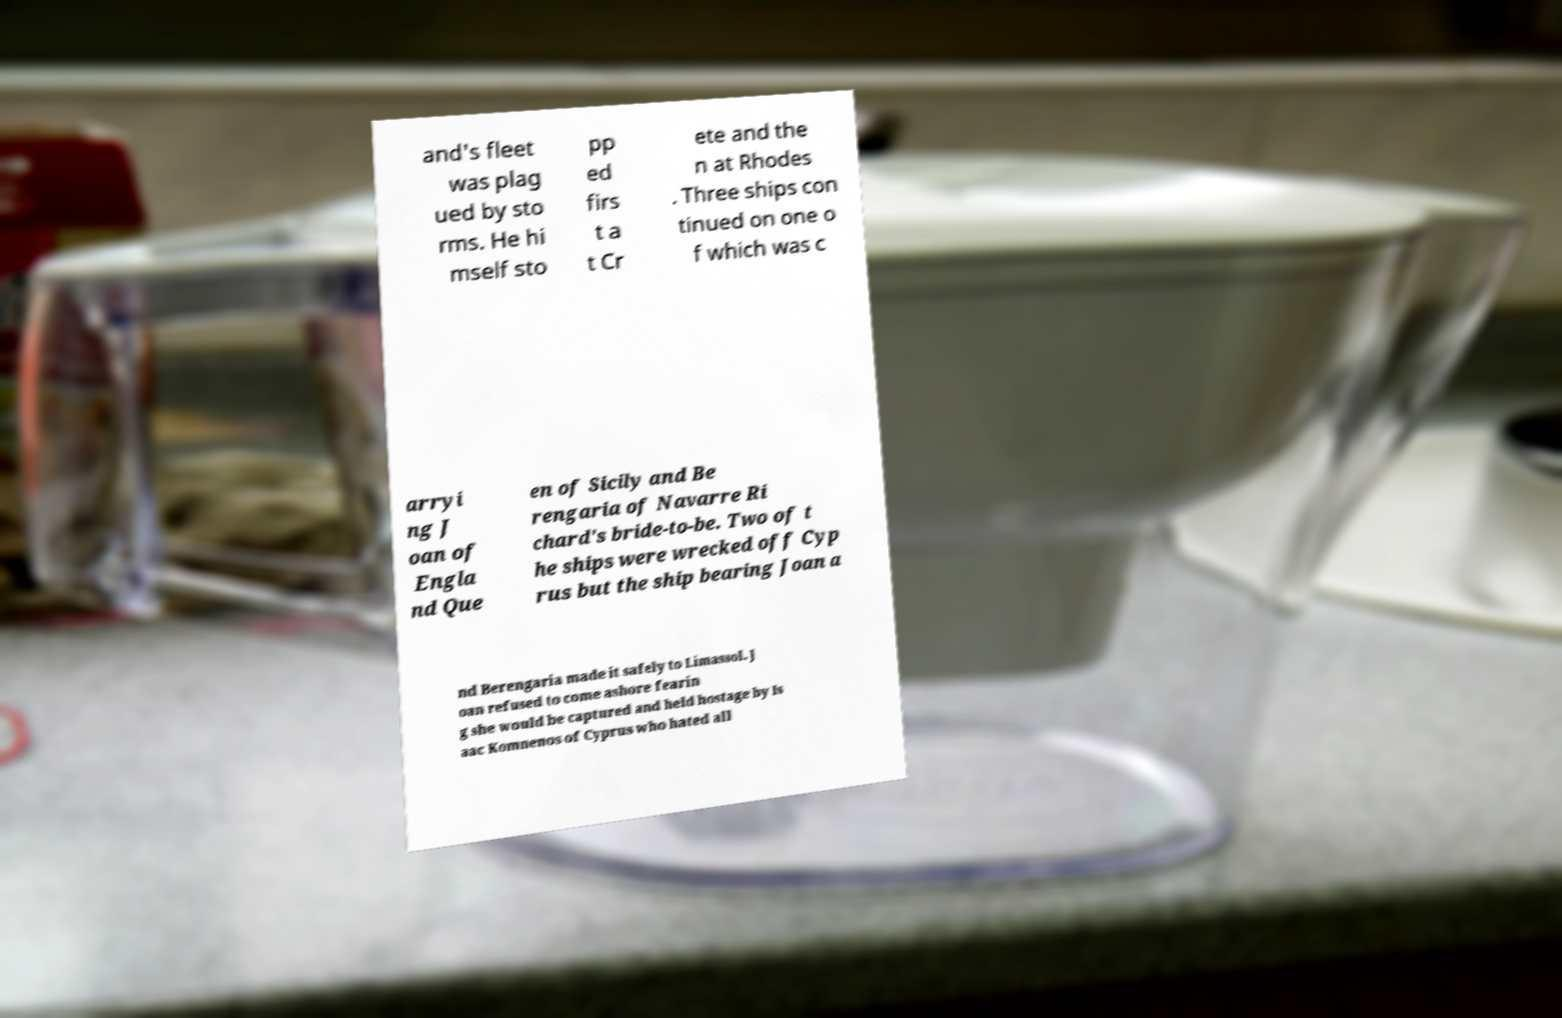Could you extract and type out the text from this image? and's fleet was plag ued by sto rms. He hi mself sto pp ed firs t a t Cr ete and the n at Rhodes . Three ships con tinued on one o f which was c arryi ng J oan of Engla nd Que en of Sicily and Be rengaria of Navarre Ri chard's bride-to-be. Two of t he ships were wrecked off Cyp rus but the ship bearing Joan a nd Berengaria made it safely to Limassol. J oan refused to come ashore fearin g she would be captured and held hostage by Is aac Komnenos of Cyprus who hated all 